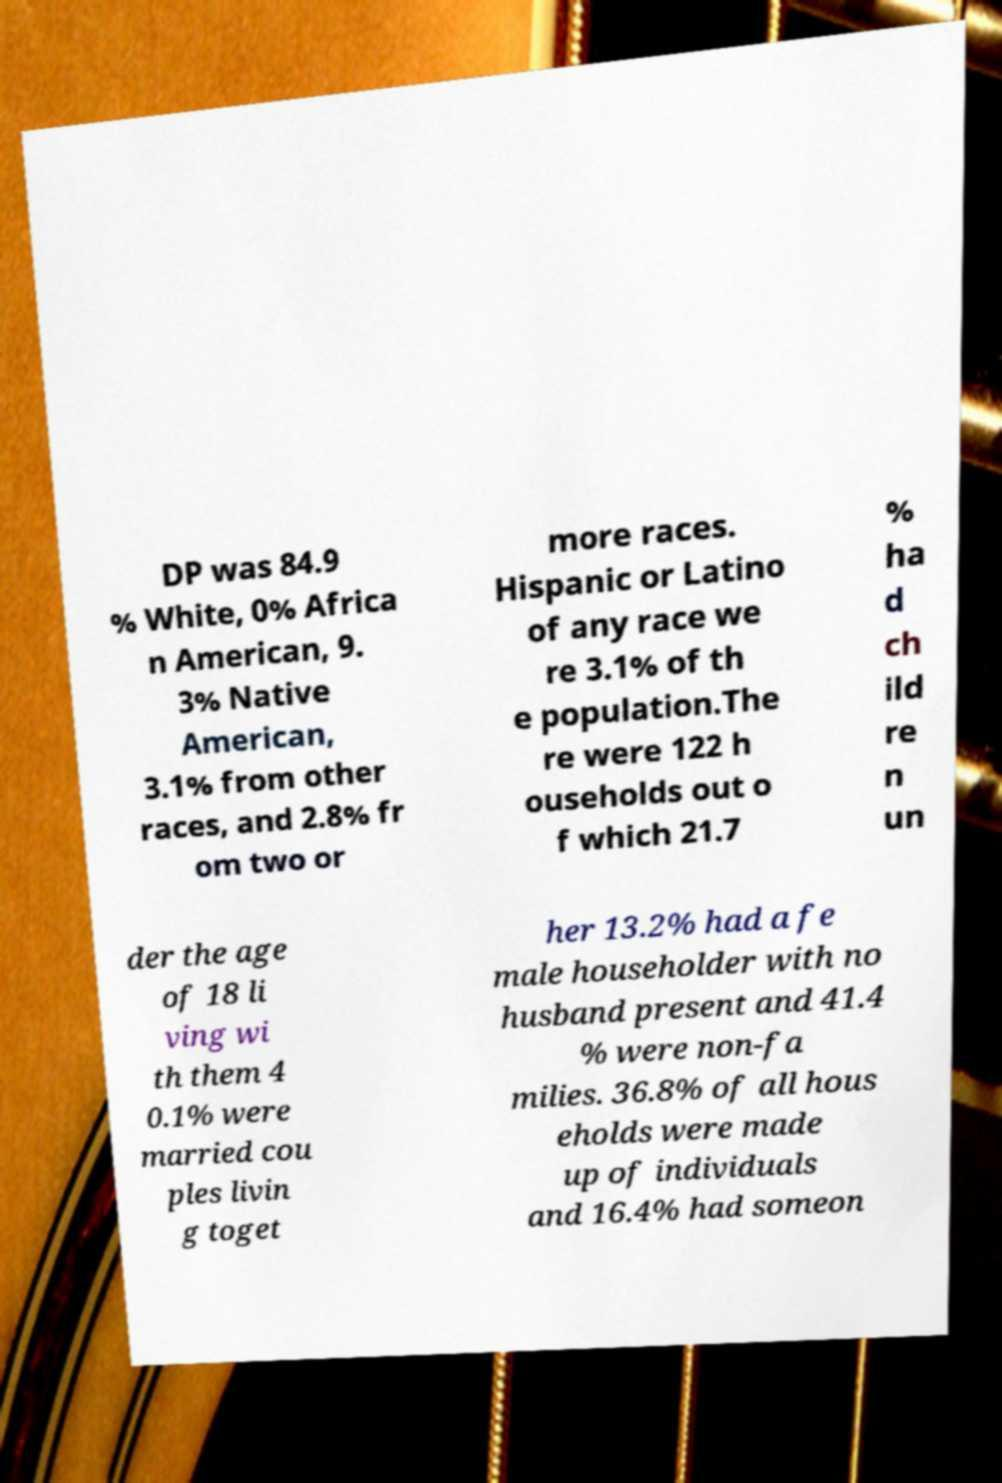Can you accurately transcribe the text from the provided image for me? DP was 84.9 % White, 0% Africa n American, 9. 3% Native American, 3.1% from other races, and 2.8% fr om two or more races. Hispanic or Latino of any race we re 3.1% of th e population.The re were 122 h ouseholds out o f which 21.7 % ha d ch ild re n un der the age of 18 li ving wi th them 4 0.1% were married cou ples livin g toget her 13.2% had a fe male householder with no husband present and 41.4 % were non-fa milies. 36.8% of all hous eholds were made up of individuals and 16.4% had someon 